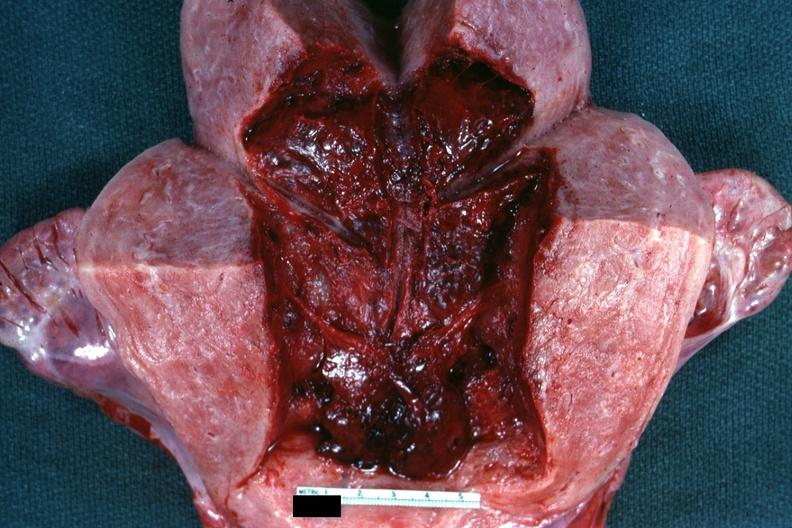what is present?
Answer the question using a single word or phrase. Female reproductive 